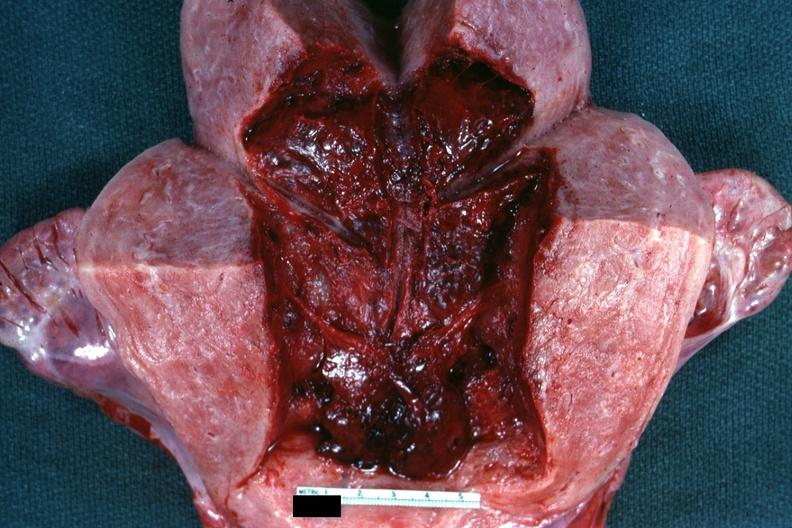what is present?
Answer the question using a single word or phrase. Female reproductive 